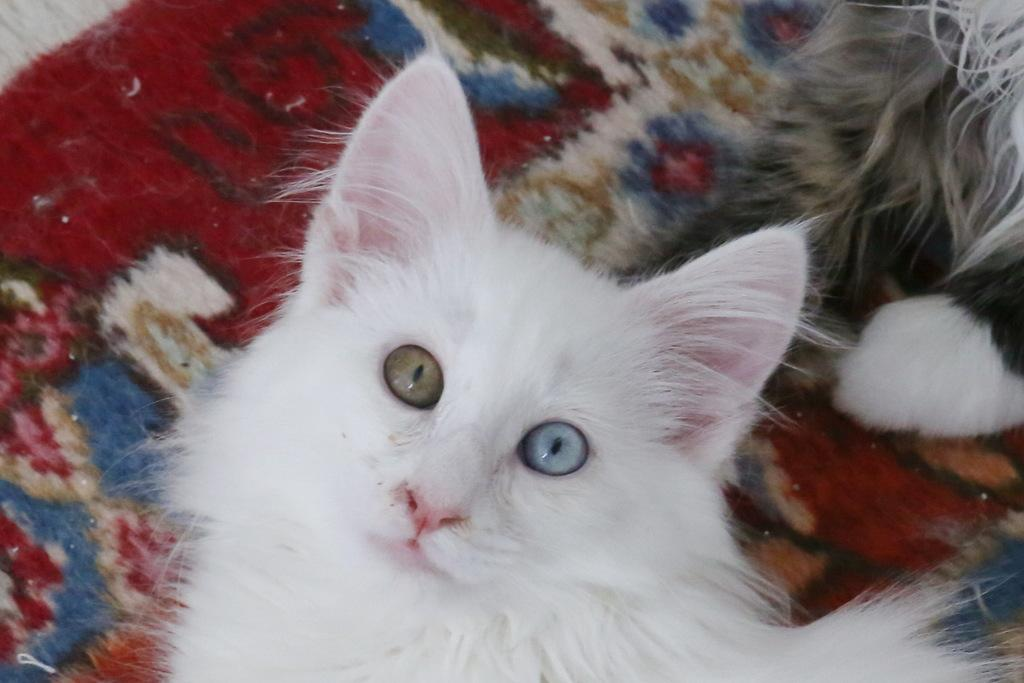What type of animal is present in the image? There is a cat in the image. What is on the floor in the image? There is a mat on the floor in the image. What type of carriage can be seen in the image? There is no carriage present in the image; it only features a cat and a mat on the floor. What material is the tin used for in the image? There is no tin present in the image. 